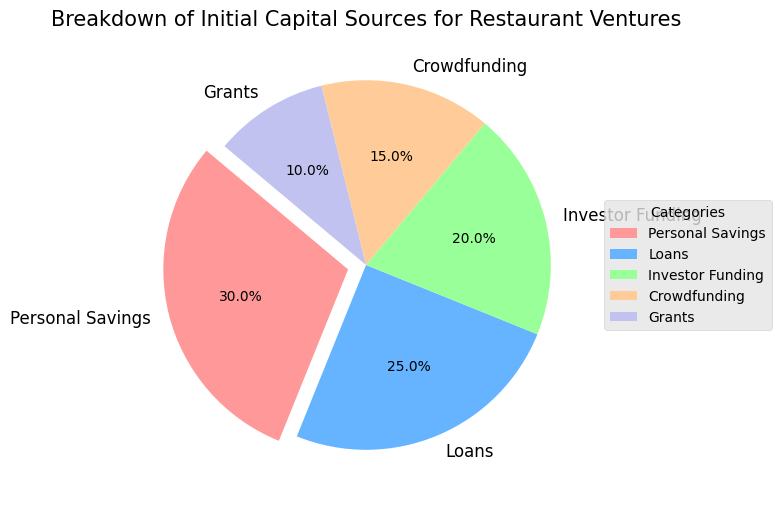what is the proportion of initial capital sources that come from loans? Referring to the pie chart, the segment for Loans is labeled with 25%, which represents the proportion of initial capital sources that come from loans.
Answer: 25% Which category has the highest percentage of initial capital sources? By examining the pie chart, the largest segment with the highest percentage is labeled Personal Savings at 30%.
Answer: Personal Savings How much greater is the percentage of Personal Savings compared to Grants? The percentage for Personal Savings is 30%, and for Grants, it is 10%. The difference between them is 30% - 10% = 20%.
Answer: 20% Combine the percentages of Loans and Investor Funding. What is the total? The chart shows Loans at 25% and Investor Funding at 20%. Adding them together gives 25% + 20% = 45%.
Answer: 45% Which category represents the smallest proportion of initial capital sources? Observing the pie chart, the smallest segment with the lowest percentage is labeled Grants at 10%.
Answer: Grants How do the percentages of Crowdfunding and Investor Funding compare? The pie chart shows Crowdfunding at 15% and Investor Funding at 20%. Comparing these, Investor Funding has a higher percentage.
Answer: Investor Funding If you combine Personal Savings, Crowdfunding, and Grants, what percentage do they represent together? Personal Savings is 30%, Crowdfunding is 15%, and Grants is 10%. Summing these gives 30% + 15% + 10% = 55%.
Answer: 55% What is the relationship between the percentages of Personal Savings and Loans? The pie chart shows Personal Savings at 30% and Loans at 25%. Thus, Personal Savings has a higher percentage compared to Loans.
Answer: Personal Savings > Loans Which category's slice is visually emphasized in the pie chart and why? The segment for Personal Savings is visually emphasized because it is slightly exploded out from the pie chart, drawing attention to its importance.
Answer: Personal Savings If the total initial capital is $100,000, how much would come from Crowdfunding? Crowdfunding represents 15% of the initial capital. 15% of $100,000 is calculated as (15/100) * $100,000 = $15,000.
Answer: $15,000 